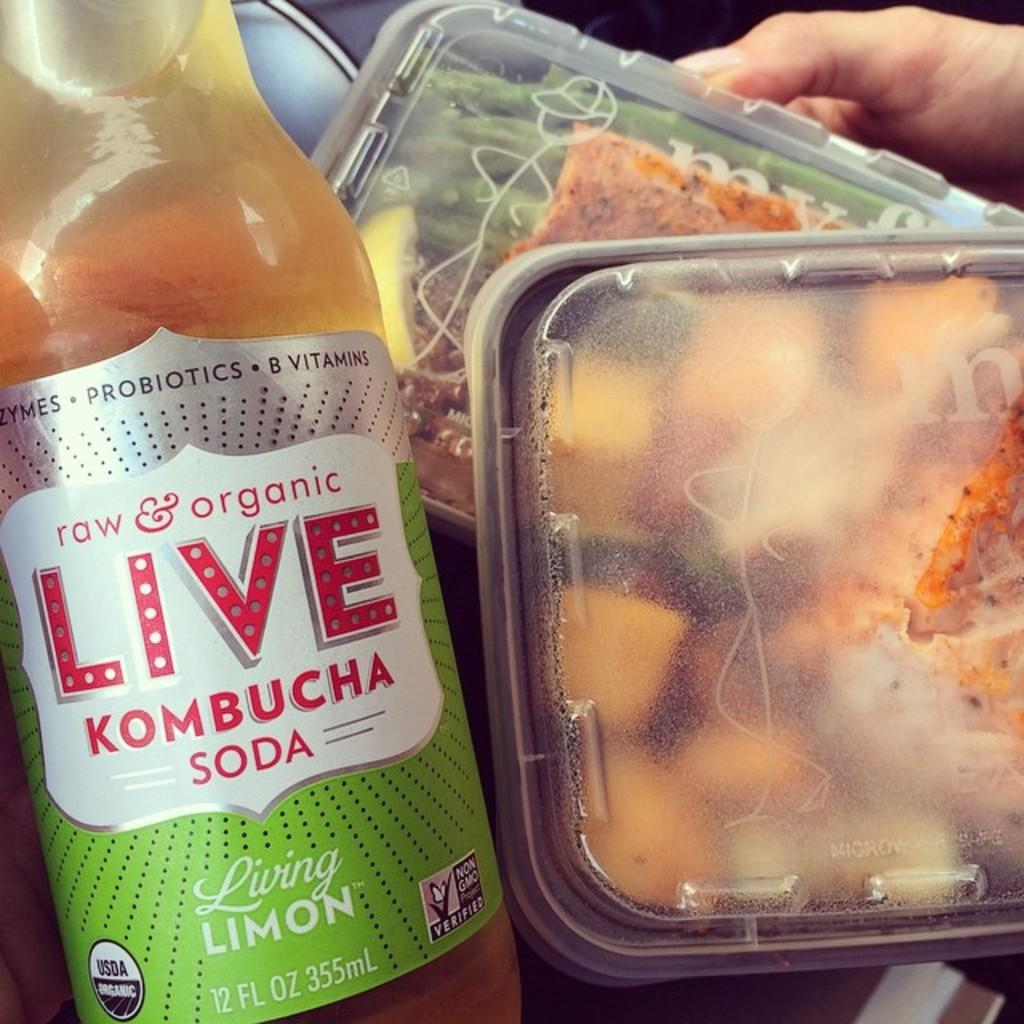Provide a one-sentence caption for the provided image. Two containers full of food sit next to a kombucha soda. 